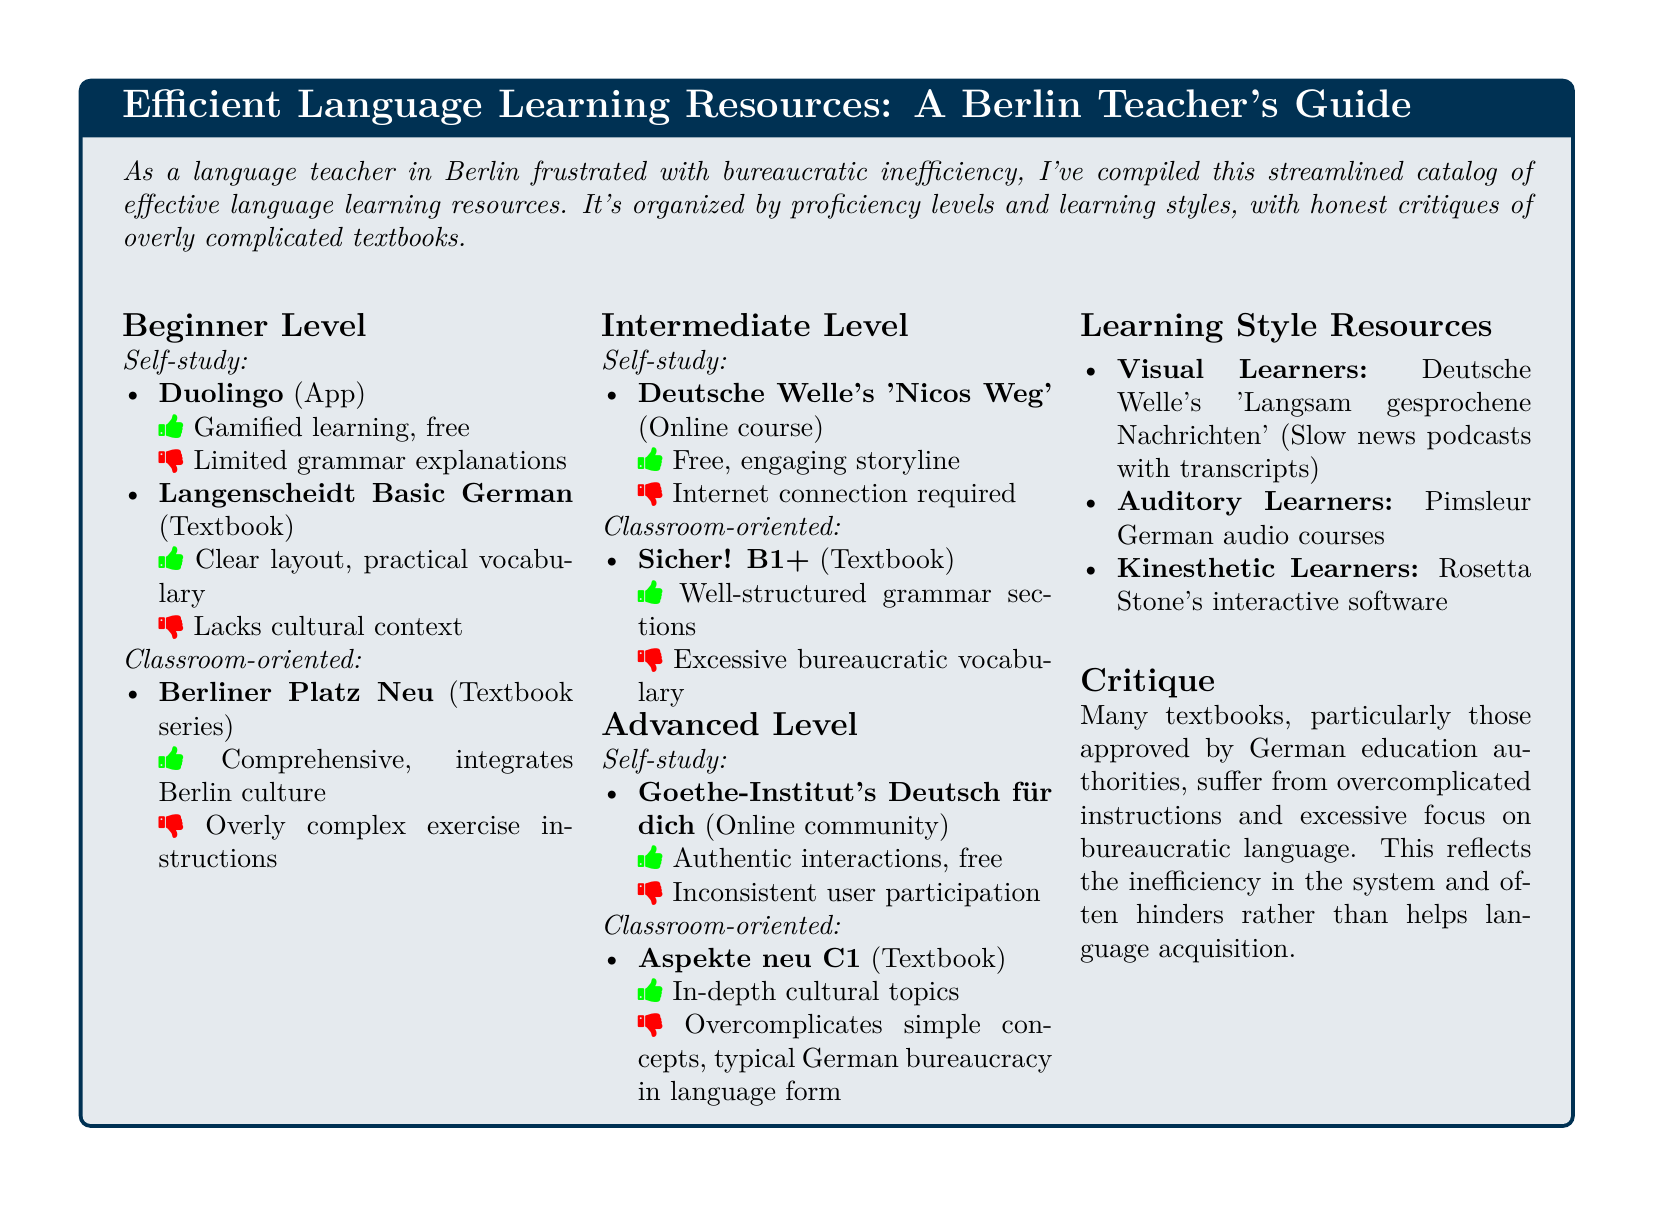What is the title of the catalog? The title is stated at the beginning of the document in the tcolorbox section.
Answer: Efficient Language Learning Resources: A Berlin Teacher's Guide How many proficiency levels are covered in the catalog? The document categorizes resources into three different proficiency levels: Beginner, Intermediate, and Advanced.
Answer: Three Which resource is recommended for visual learners? The document mentions a specific resource for visual learners under the Learning Style Resources section.
Answer: Deutsche Welle's 'Langsam gesprochene Nachrichten' What critique is made about many textbooks? The critique section highlights an aspect regarding the textbooks approved by German authorities affecting language acquisition.
Answer: Overcomplicated instructions and excessive focus on bureaucratic language What is the main feature of the resource "Duolingo"? The document lists characteristics of Duolingo under the self-study beginner level resources.
Answer: Gamified learning, free Which textbook series is mentioned for classroom-oriented beginners? The resources under the Classroom-oriented category for beginners list this specific series.
Answer: Berliner Platz Neu 